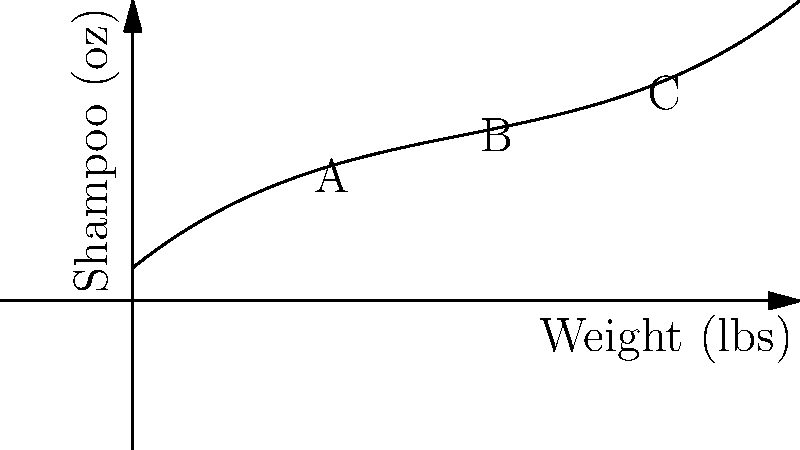The graph shows the relationship between a dog's weight and the amount of shampoo needed for grooming. Points A, B, and C represent dogs of different weights. Which point represents the dog that requires the most shampoo per pound of body weight? To determine which dog requires the most shampoo per pound of body weight, we need to calculate the ratio of shampoo to weight for each point:

1. Point A (10 lbs):
   Shampoo amount ≈ 9 oz
   Ratio = 9 oz / 10 lbs = 0.9 oz/lb

2. Point B (20 lbs):
   Shampoo amount ≈ 12 oz
   Ratio = 12 oz / 20 lbs = 0.6 oz/lb

3. Point C (30 lbs):
   Shampoo amount ≈ 15 oz
   Ratio = 15 oz / 30 lbs = 0.5 oz/lb

The highest ratio is at Point A, indicating that the smallest dog requires the most shampoo per pound of body weight.
Answer: Point A 